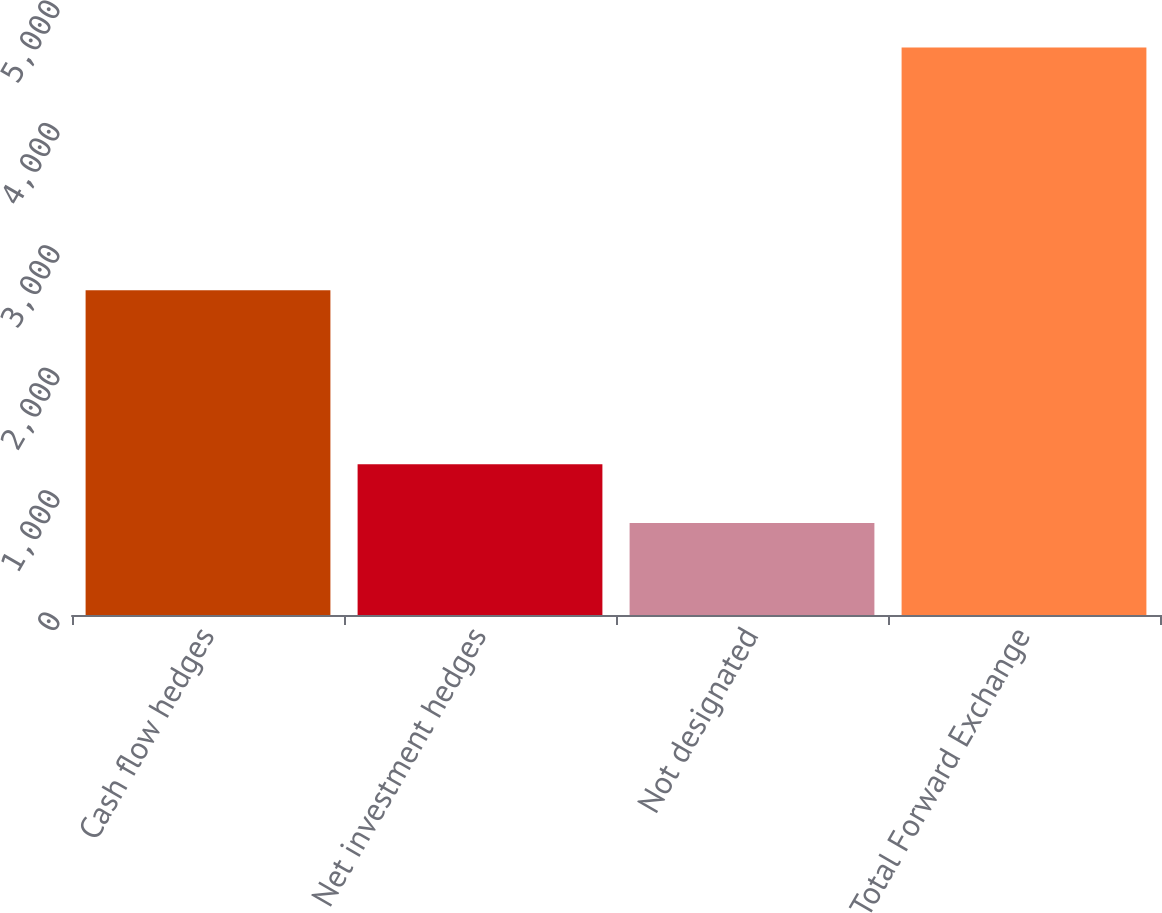<chart> <loc_0><loc_0><loc_500><loc_500><bar_chart><fcel>Cash flow hedges<fcel>Net investment hedges<fcel>Not designated<fcel>Total Forward Exchange<nl><fcel>2653.4<fcel>1231.8<fcel>751.9<fcel>4637.1<nl></chart> 